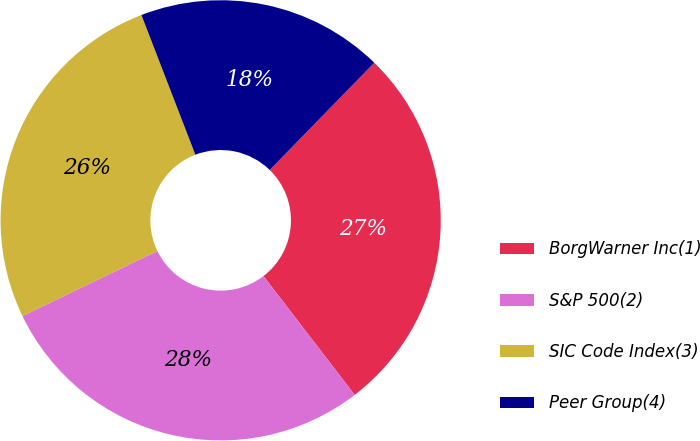Convert chart to OTSL. <chart><loc_0><loc_0><loc_500><loc_500><pie_chart><fcel>BorgWarner Inc(1)<fcel>S&P 500(2)<fcel>SIC Code Index(3)<fcel>Peer Group(4)<nl><fcel>27.28%<fcel>28.26%<fcel>26.3%<fcel>18.16%<nl></chart> 